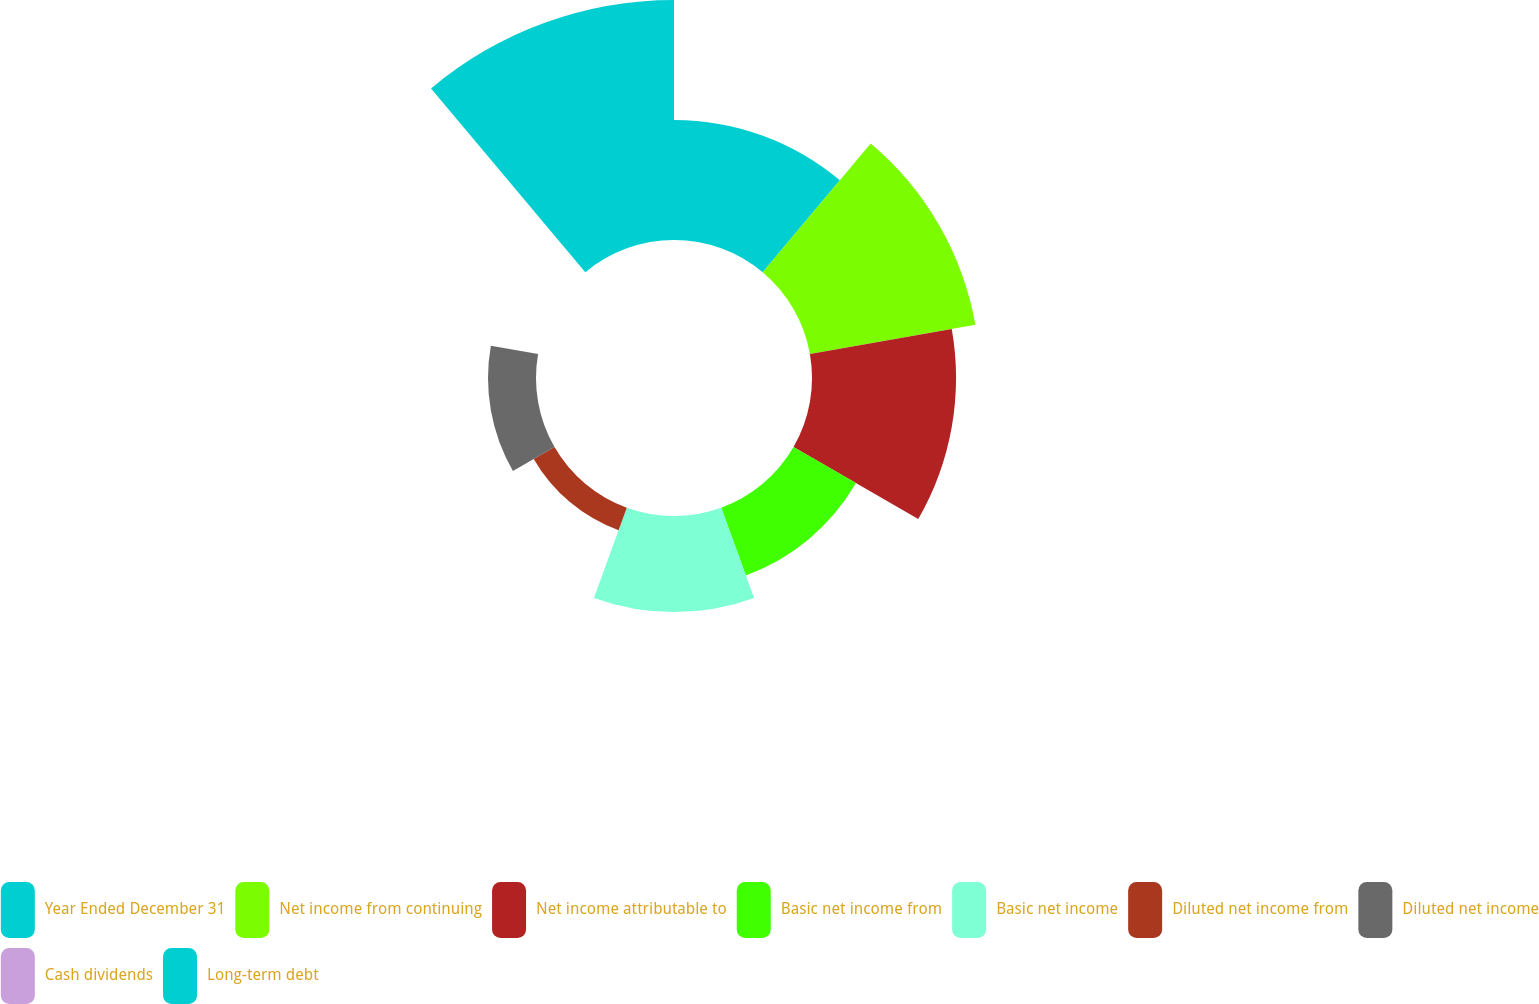Convert chart to OTSL. <chart><loc_0><loc_0><loc_500><loc_500><pie_chart><fcel>Year Ended December 31<fcel>Net income from continuing<fcel>Net income attributable to<fcel>Basic net income from<fcel>Basic net income<fcel>Diluted net income from<fcel>Diluted net income<fcel>Cash dividends<fcel>Long-term debt<nl><fcel>13.16%<fcel>18.42%<fcel>15.79%<fcel>7.9%<fcel>10.53%<fcel>2.63%<fcel>5.26%<fcel>0.0%<fcel>26.31%<nl></chart> 